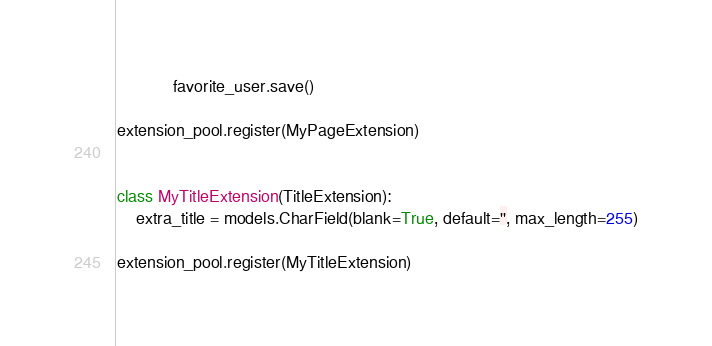<code> <loc_0><loc_0><loc_500><loc_500><_Python_>            favorite_user.save()

extension_pool.register(MyPageExtension)


class MyTitleExtension(TitleExtension):
    extra_title = models.CharField(blank=True, default='', max_length=255)

extension_pool.register(MyTitleExtension)
</code> 